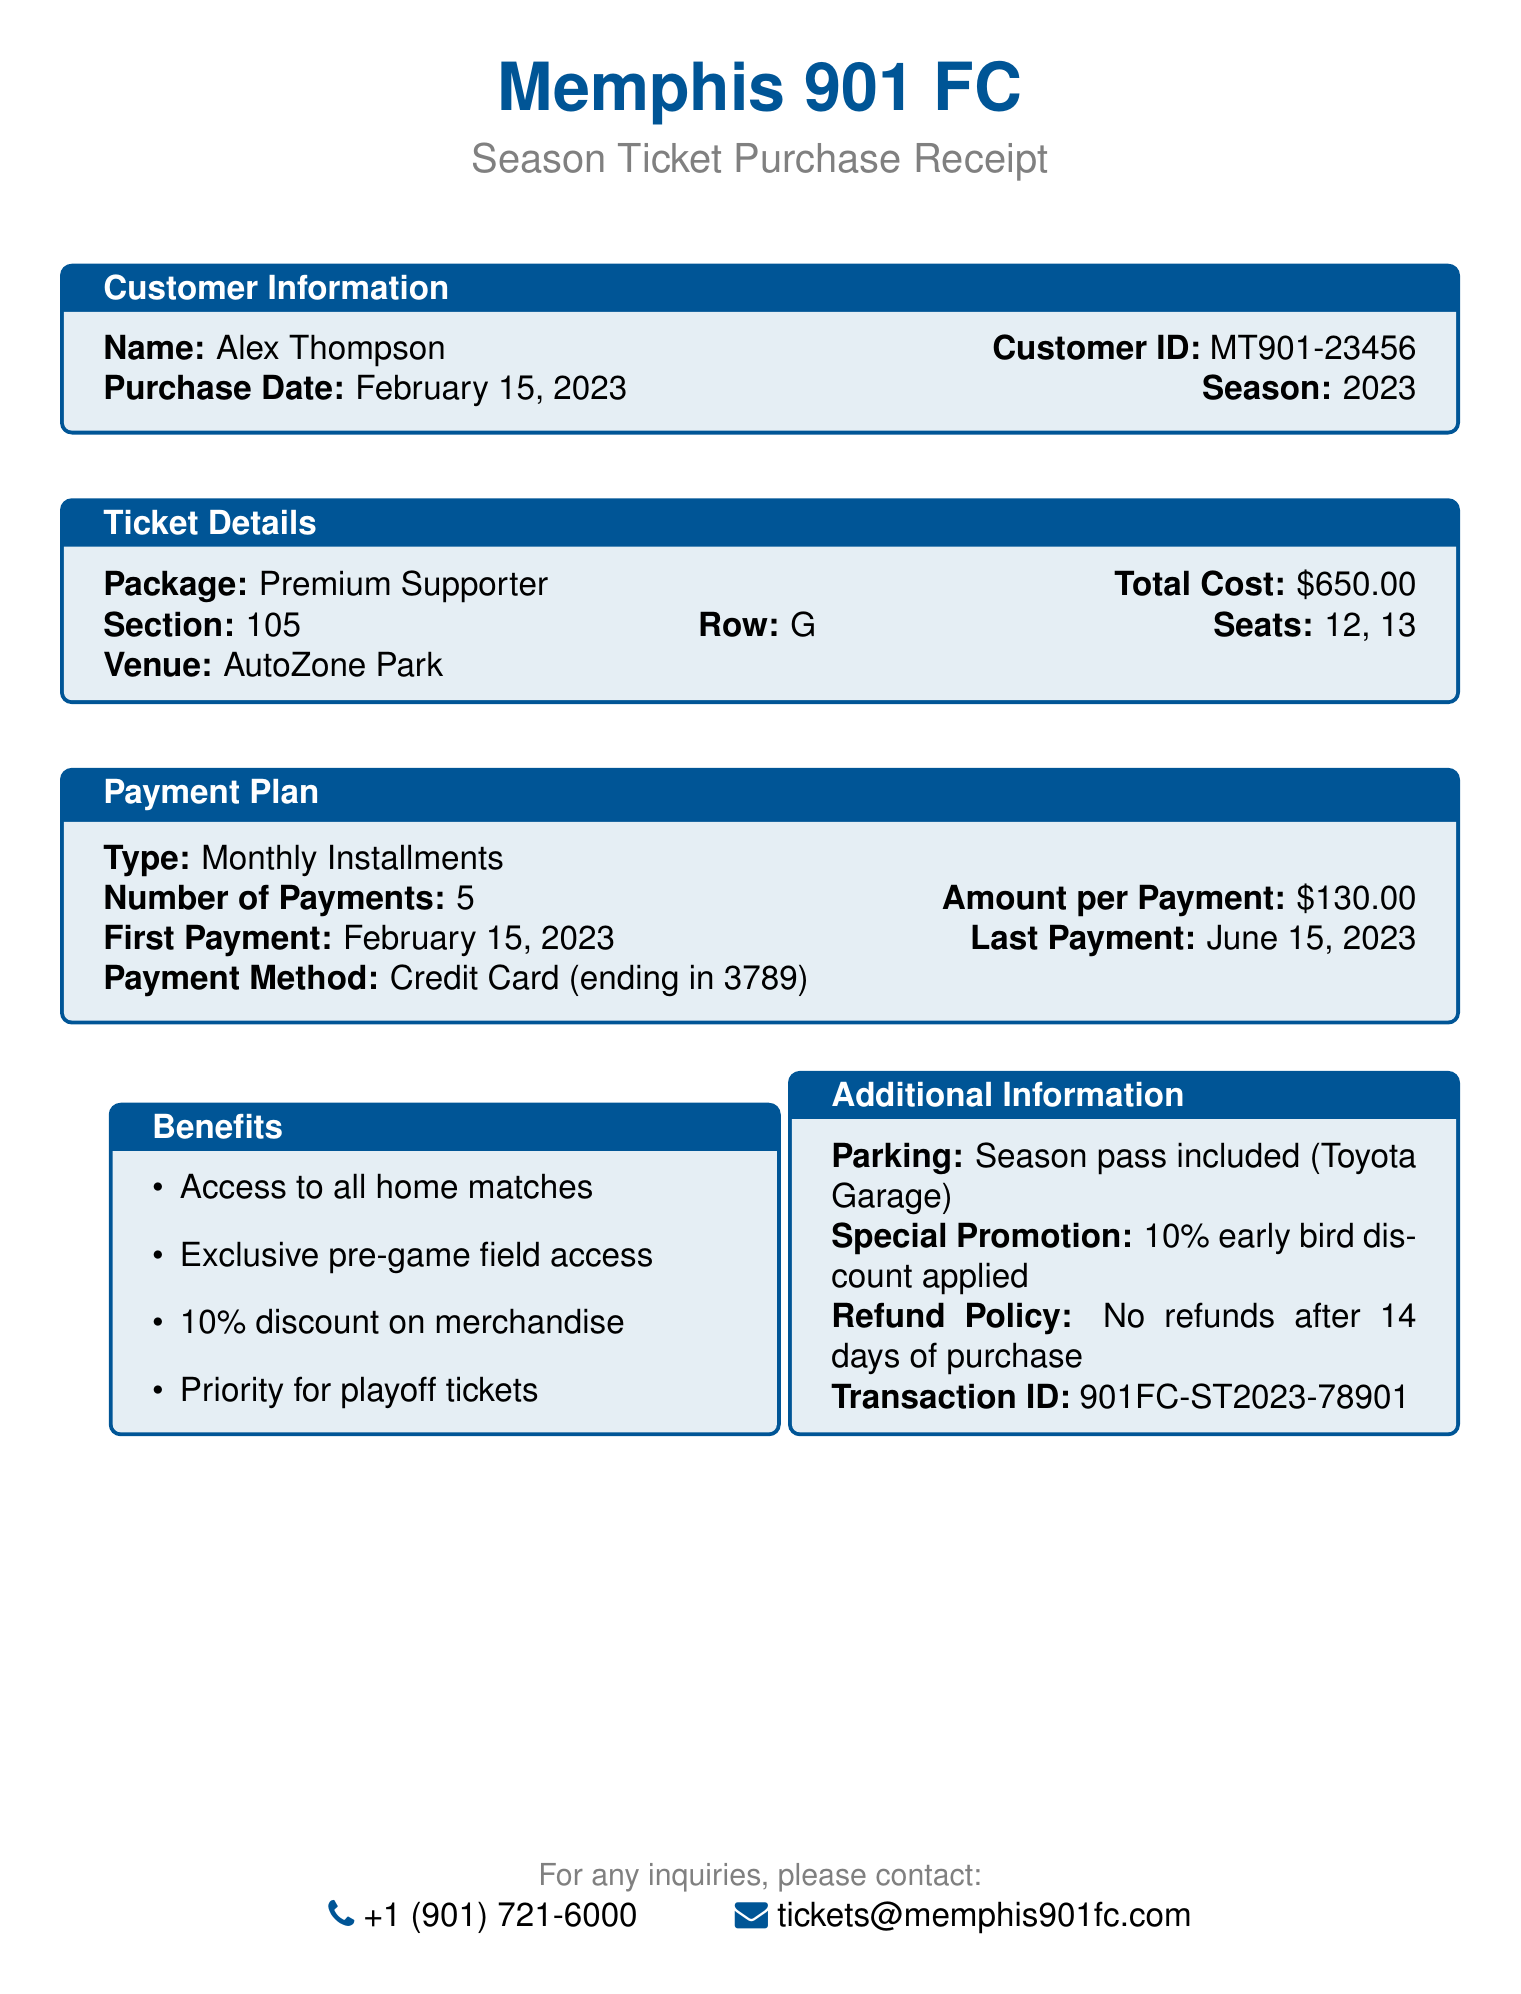What is the customer name? The customer name is specified in the customer information section of the document.
Answer: Alex Thompson What is the season for the purchased tickets? The season for the purchased tickets is clearly mentioned in the document.
Answer: 2023 What is the total cost of the season tickets? The total cost is listed as part of the ticket details.
Answer: $650.00 How many seats were purchased? The number of seats can be counted from the seat details provided in the document.
Answer: 2 What is the payment method used? The payment method is detailed in the payment plan section.
Answer: Credit Card What is the first payment date? The first payment date can be found under the payment plan details of the document.
Answer: February 15, 2023 Which section are the seats located in? The section where the seats are located is specified in the ticket details of the document.
Answer: 105 What benefits are included with the ticket package? The benefits can be found listed under the benefits section of the document.
Answer: Access to all home matches, Exclusive pre-game field access, 10% discount on merchandise, Priority for playoff tickets What is the refund policy? The refund policy is provided in the additional information section.
Answer: No refunds after 14 days of purchase. Exchanges allowed up to 24 hours before match day What is the phone number for the ticket office? The contact information section lists the phone number for inquiries.
Answer: +1 (901) 721-6000 